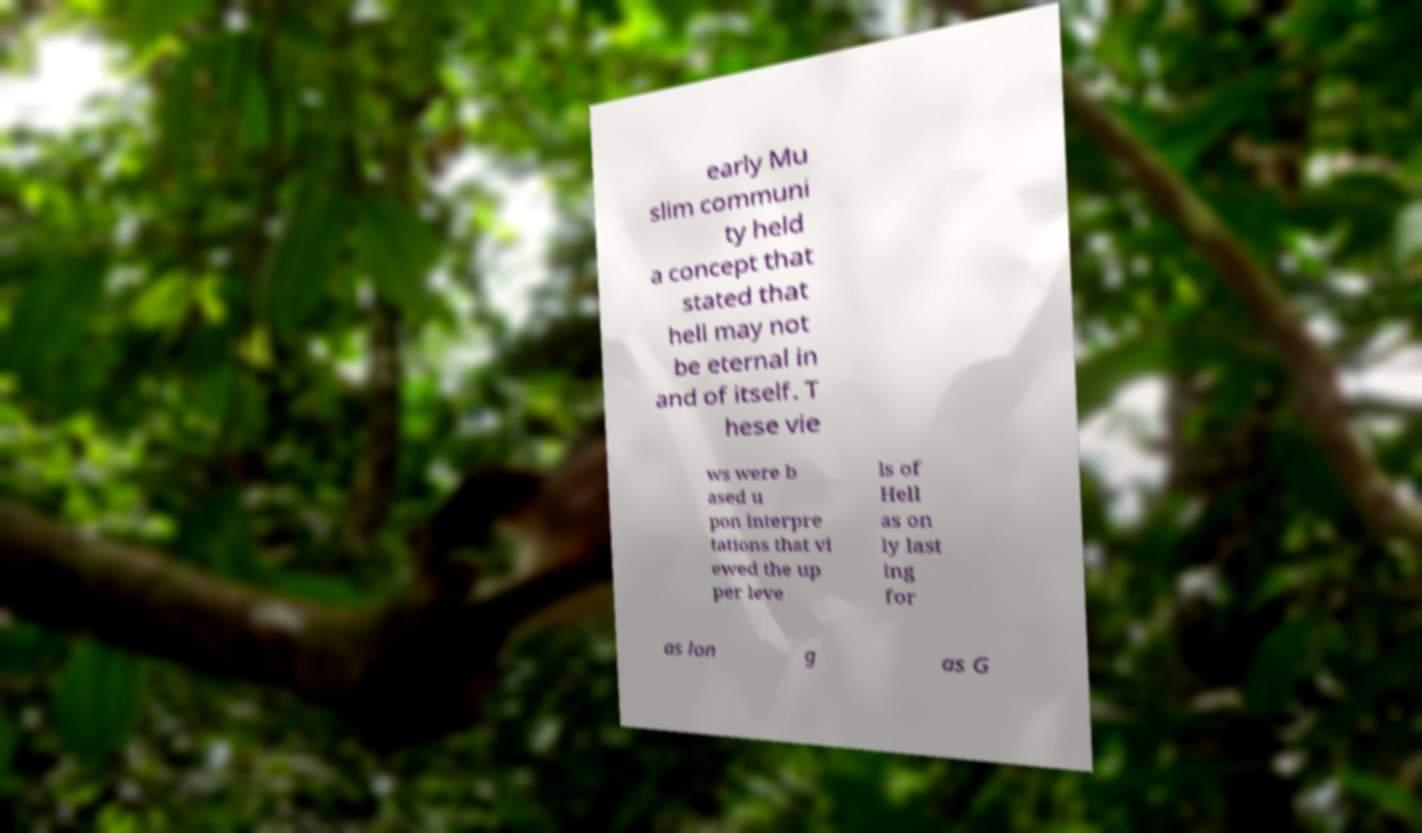For documentation purposes, I need the text within this image transcribed. Could you provide that? early Mu slim communi ty held a concept that stated that hell may not be eternal in and of itself. T hese vie ws were b ased u pon interpre tations that vi ewed the up per leve ls of Hell as on ly last ing for as lon g as G 